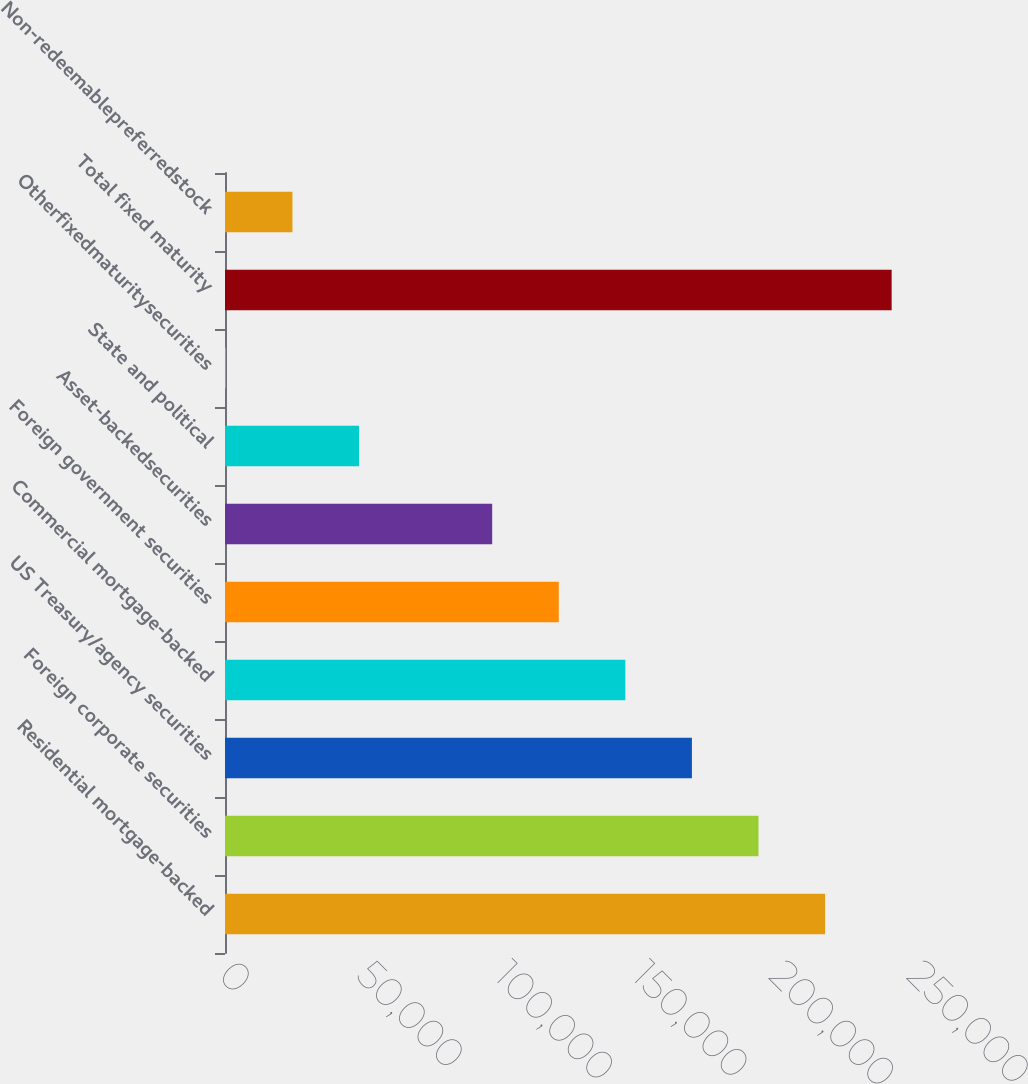Convert chart. <chart><loc_0><loc_0><loc_500><loc_500><bar_chart><fcel>Residential mortgage-backed<fcel>Foreign corporate securities<fcel>US Treasury/agency securities<fcel>Commercial mortgage-backed<fcel>Foreign government securities<fcel>Asset-backedsecurities<fcel>State and political<fcel>Otherfixedmaturitysecurities<fcel>Total fixed maturity<fcel>Non-redeemablepreferredstock<nl><fcel>218050<fcel>193857<fcel>169665<fcel>145472<fcel>121280<fcel>97087.6<fcel>48702.8<fcel>318<fcel>242242<fcel>24510.4<nl></chart> 